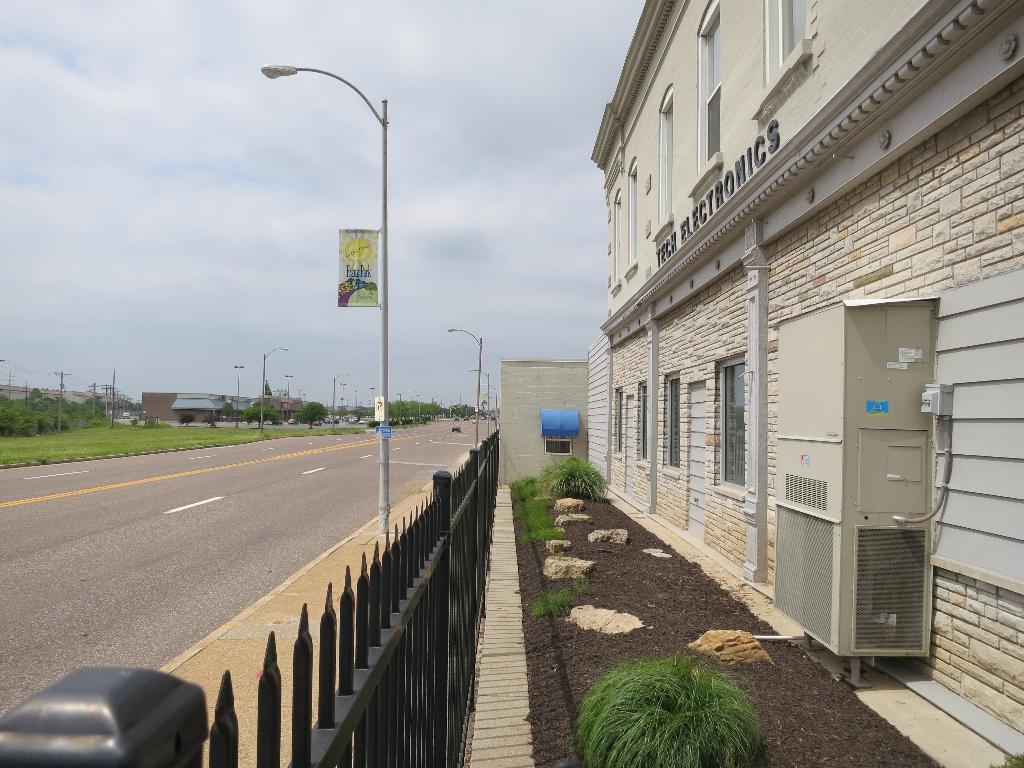What type of structures can be seen in the image? There are buildings in the image. What type of vegetation is present in the image? There are trees and plants in the image. What type of man-made objects can be seen in the image? There are poles and a fence in the image. What type of natural elements can be seen in the image? There are stones in the image. What type of transportation is present in the image? There are vehicles on the road in the image. What is visible at the top of the image? The sky is visible at the top of the image. Where is the map located in the image? There is no map present in the image. What type of hat is the person wearing in the image? There are no people or hats present in the image. What type of office furniture can be seen in the image? There is no office furniture present in the image. 